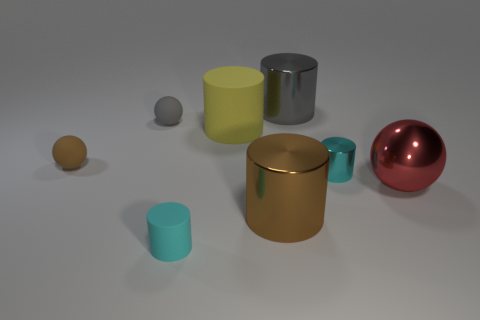What is the shape of the tiny thing to the right of the small matte cylinder?
Your answer should be very brief. Cylinder. There is a brown thing that is to the left of the yellow matte cylinder; is there a big object behind it?
Provide a short and direct response. Yes. Are there any yellow rubber cylinders that have the same size as the brown metal object?
Offer a very short reply. Yes. Do the tiny matte cylinder in front of the tiny cyan shiny thing and the small shiny cylinder have the same color?
Your answer should be compact. Yes. The gray cylinder has what size?
Make the answer very short. Large. What is the size of the ball to the right of the big metallic cylinder behind the tiny gray ball?
Offer a very short reply. Large. What number of matte things are the same color as the tiny shiny cylinder?
Provide a short and direct response. 1. How many small cyan things are there?
Your response must be concise. 2. How many small objects are made of the same material as the yellow cylinder?
Offer a terse response. 3. What is the size of the gray object that is the same shape as the large red metal object?
Offer a terse response. Small. 